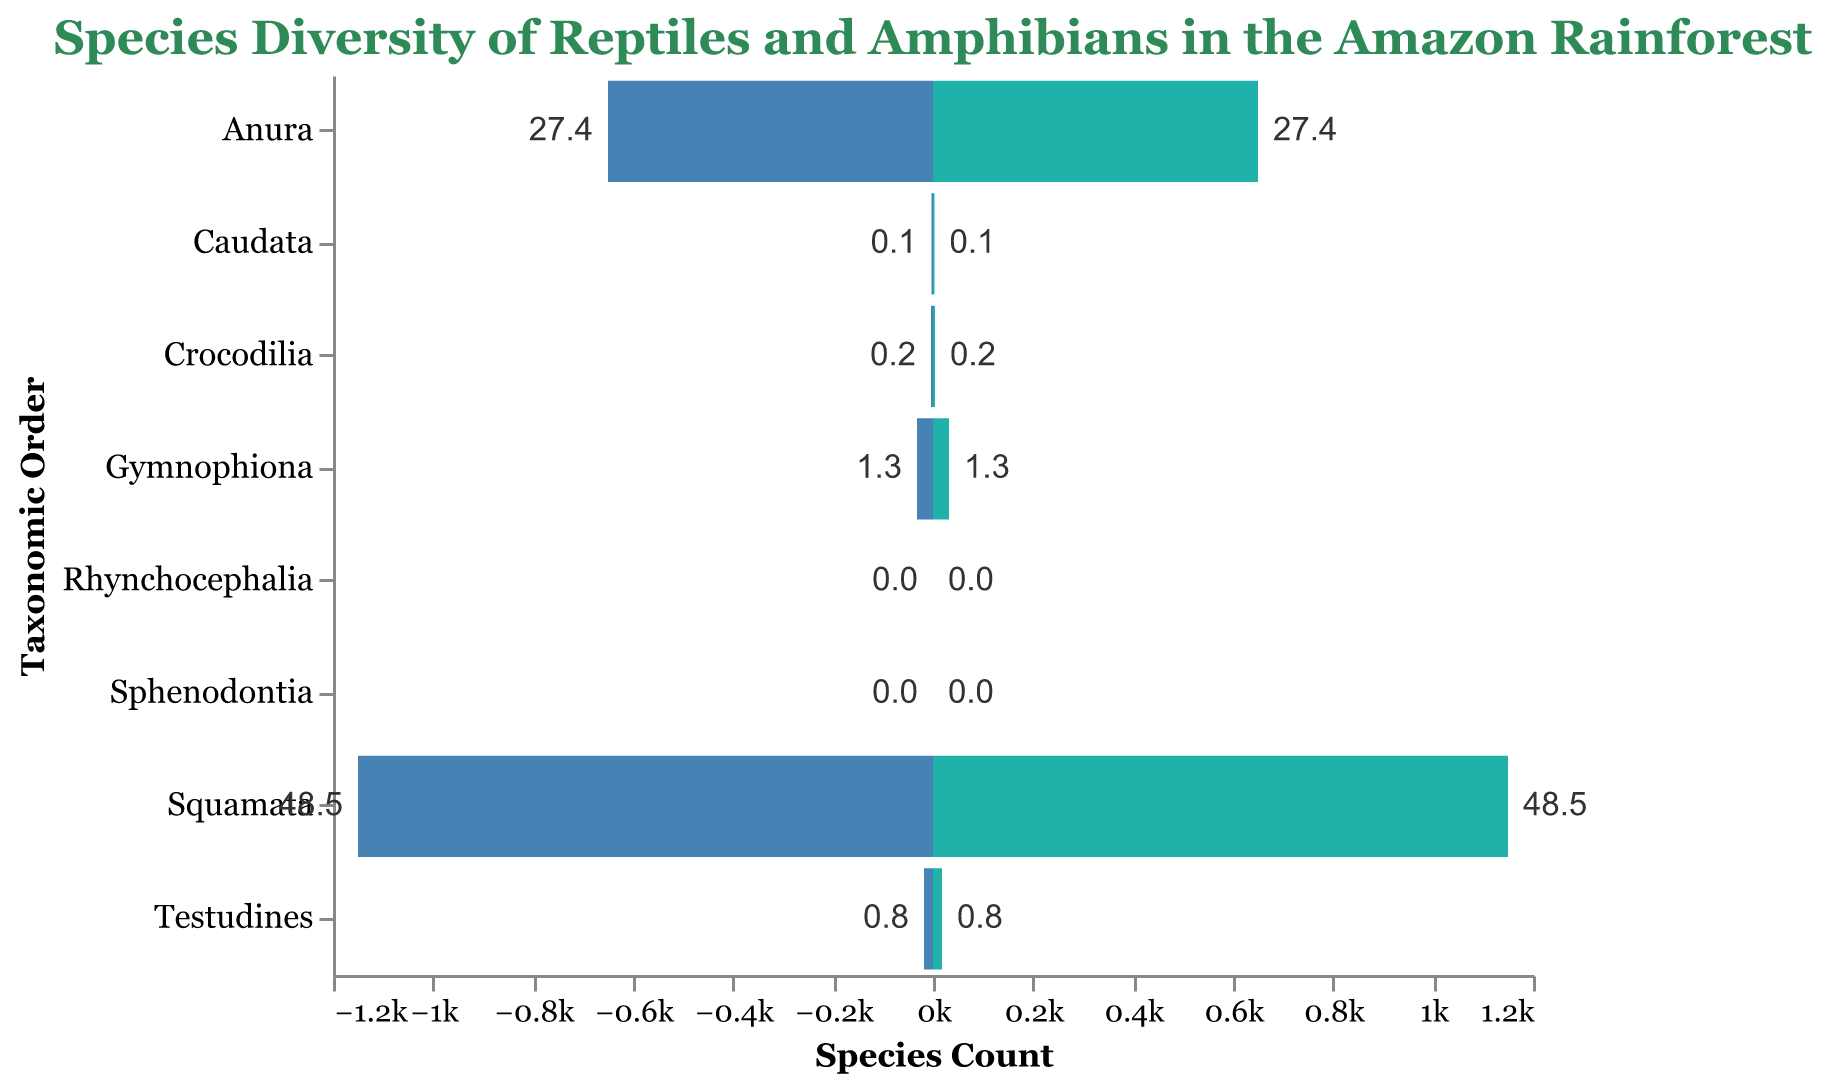What is the title of the figure? The title of the figure is shown at the top and reads: "Species Diversity of Reptiles and Amphibians in the Amazon Rainforest".
Answer: Species Diversity of Reptiles and Amphibians in the Amazon Rainforest Which taxonomic order has the highest species count? By looking at the lengths of the bars, the taxonomic order with the highest species count is Squamata.
Answer: Squamata How many species are in the Anura order? By looking at the length of the bar corresponding to the Anura order, it shows a species count of 650.
Answer: 650 Which orders have a species count of zero? The figure shows that the Rhynchocephalia and Sphenodontia orders both have bars of zero length, indicating their species counts are zero.
Answer: Rhynchocephalia and Sphenodontia What percentage of the species are in the Gymnophiona order? The text annotations on the bars indicate that the Gymnophiona order comprises 1.3% of the species.
Answer: 1.3% What is the combined species count of Testudines and Crocodilia? The species count for Testudines is 18 and for Crocodilia is 4. Adding these together, 18 + 4 = 22.
Answer: 22 Which order has the smallest species count, and how many species does it have? Looking at the lengths of the bars, the order Caudata has the smallest non-zero species count, which is 3.
Answer: Caudata, 3 Compare the species count of the Squamata order to that of the Anura order. How many more species are there in Squamata than in Anura? The species count for Squamata is 1150 and for Anura is 650. Subtracting these, 1150 - 650 = 500.
Answer: 500 How does the percentage of species in the Anura order compare to that in the Squamata order? Anura has 27.4% of the species, while Squamata has 48.5%. The difference is 48.5% - 27.4% = 21.1%.
Answer: 21.1% more in Squamata What is the total percentage of species represented by Squamata and Anura orders? The percentages for Squamata and Anura are 48.5% and 27.4% respectively. Adding these together, 48.5% + 27.4% = 75.9%.
Answer: 75.9% 